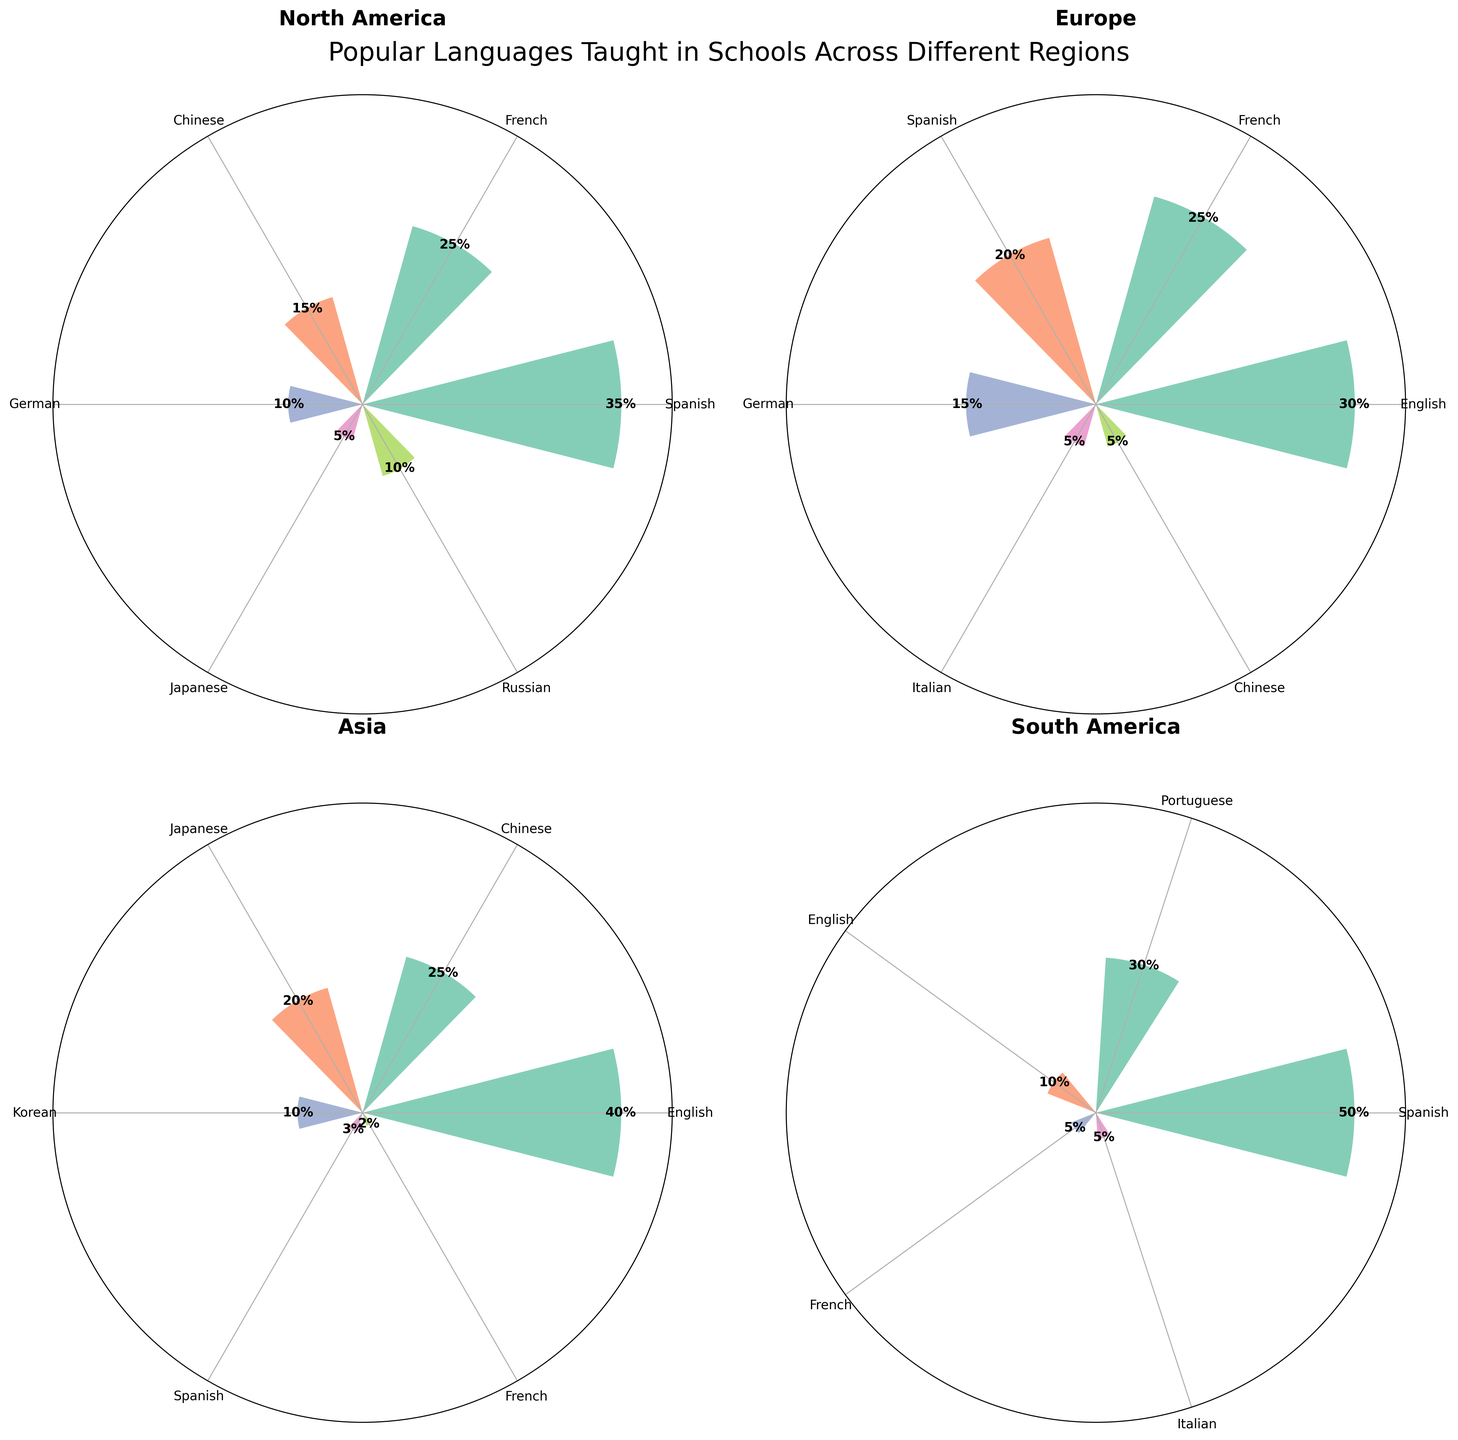What are the most popular languages taught in North America? In the polar area chart for North America, we can observe that Spanish, French, and Chinese have the largest segments. Therefore, these are the most popular languages taught in that region.
Answer: Spanish, French, Chinese Which region has the highest popularity percentage for learning Chinese? By comparing the Chinese segments in each region, the polar area chart shows that Asia has the largest segment for Chinese with 25%, compared to North America (15%) and Europe (5%).
Answer: Asia What is the total popularity percentage of European languages (English, French, Spanish, German, and Italian)? To find the total, we sum the popularity percentages of these languages in Europe: English (30%), French (25%), Spanish (20%), German (15%), and Italian (5%). This results in 30 + 25 + 20 + 15 + 5 = 95%.
Answer: 95% Compare the popularity of Spanish in South America and North America. Which region has a higher percentage? The polar area chart indicates that South America has a 50% popularity for Spanish, while North America has 35%. Therefore, South America has a higher percentage for Spanish.
Answer: South America How many languages are reported for each region? By counting the theta ticks (each representing a language) in each of the four polar area charts, we see that North America has 6 languages, Europe has 6, Asia has 6, and South America has 5.
Answer: North America: 6, Europe: 6, Asia: 6, South America: 5 What is the least popular language in Europe according to the chart? The chart shows that Chinese and Italian both have the smallest segments in Europe, each with a 5% popularity.
Answer: Chinese, Italian Which region has the widest variety of popular languages taught? Comparing the number of languages visually depicted in each polar chart, we see that North America, Europe, and Asia each have 6 languages, while South America has 5. Therefore, North America, Europe, and Asia have the widest variety.
Answer: North America, Europe, Asia Is French more popular in North America or Asia? Comparing the French segments in both regions, the chart shows that North America has a 25% popularity for French, while Asia has only 2%. Thus, French is more popular in North America.
Answer: North America In Asia, how many times more popular is English compared to French? In Asia, English has a popularity of 40%, while French has 2%. To find how many times more popular English is, we calculate 40/2 = 20.
Answer: 20 times Which language is uniquely most popular in any region? By observing the charts, Spanish in South America makes up 50% of the popularity, which is the highest single-language percentage in any region.
Answer: Spanish in South America 